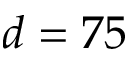<formula> <loc_0><loc_0><loc_500><loc_500>d = 7 5</formula> 